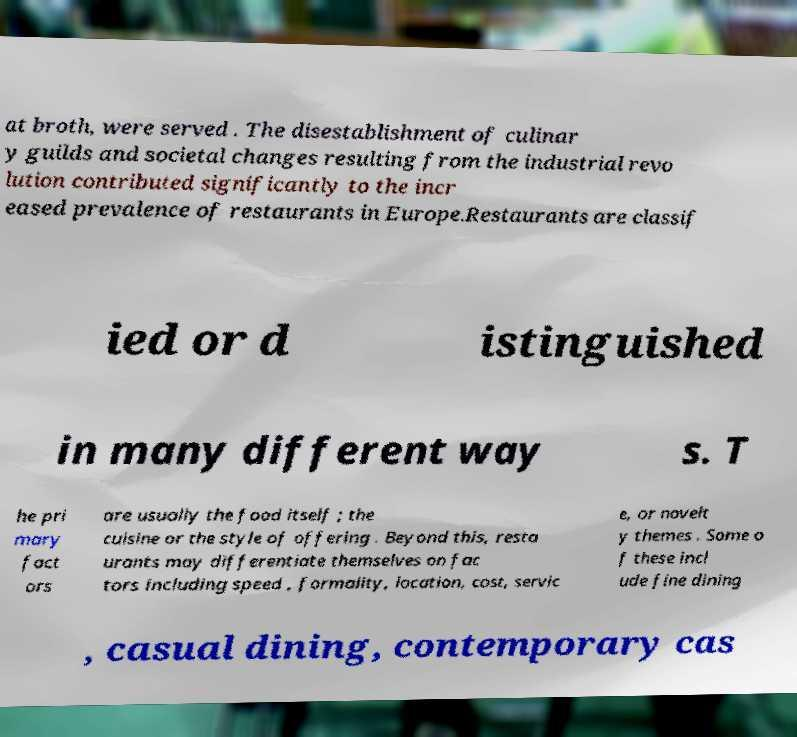Can you accurately transcribe the text from the provided image for me? at broth, were served . The disestablishment of culinar y guilds and societal changes resulting from the industrial revo lution contributed significantly to the incr eased prevalence of restaurants in Europe.Restaurants are classif ied or d istinguished in many different way s. T he pri mary fact ors are usually the food itself ; the cuisine or the style of offering . Beyond this, resta urants may differentiate themselves on fac tors including speed , formality, location, cost, servic e, or novelt y themes . Some o f these incl ude fine dining , casual dining, contemporary cas 